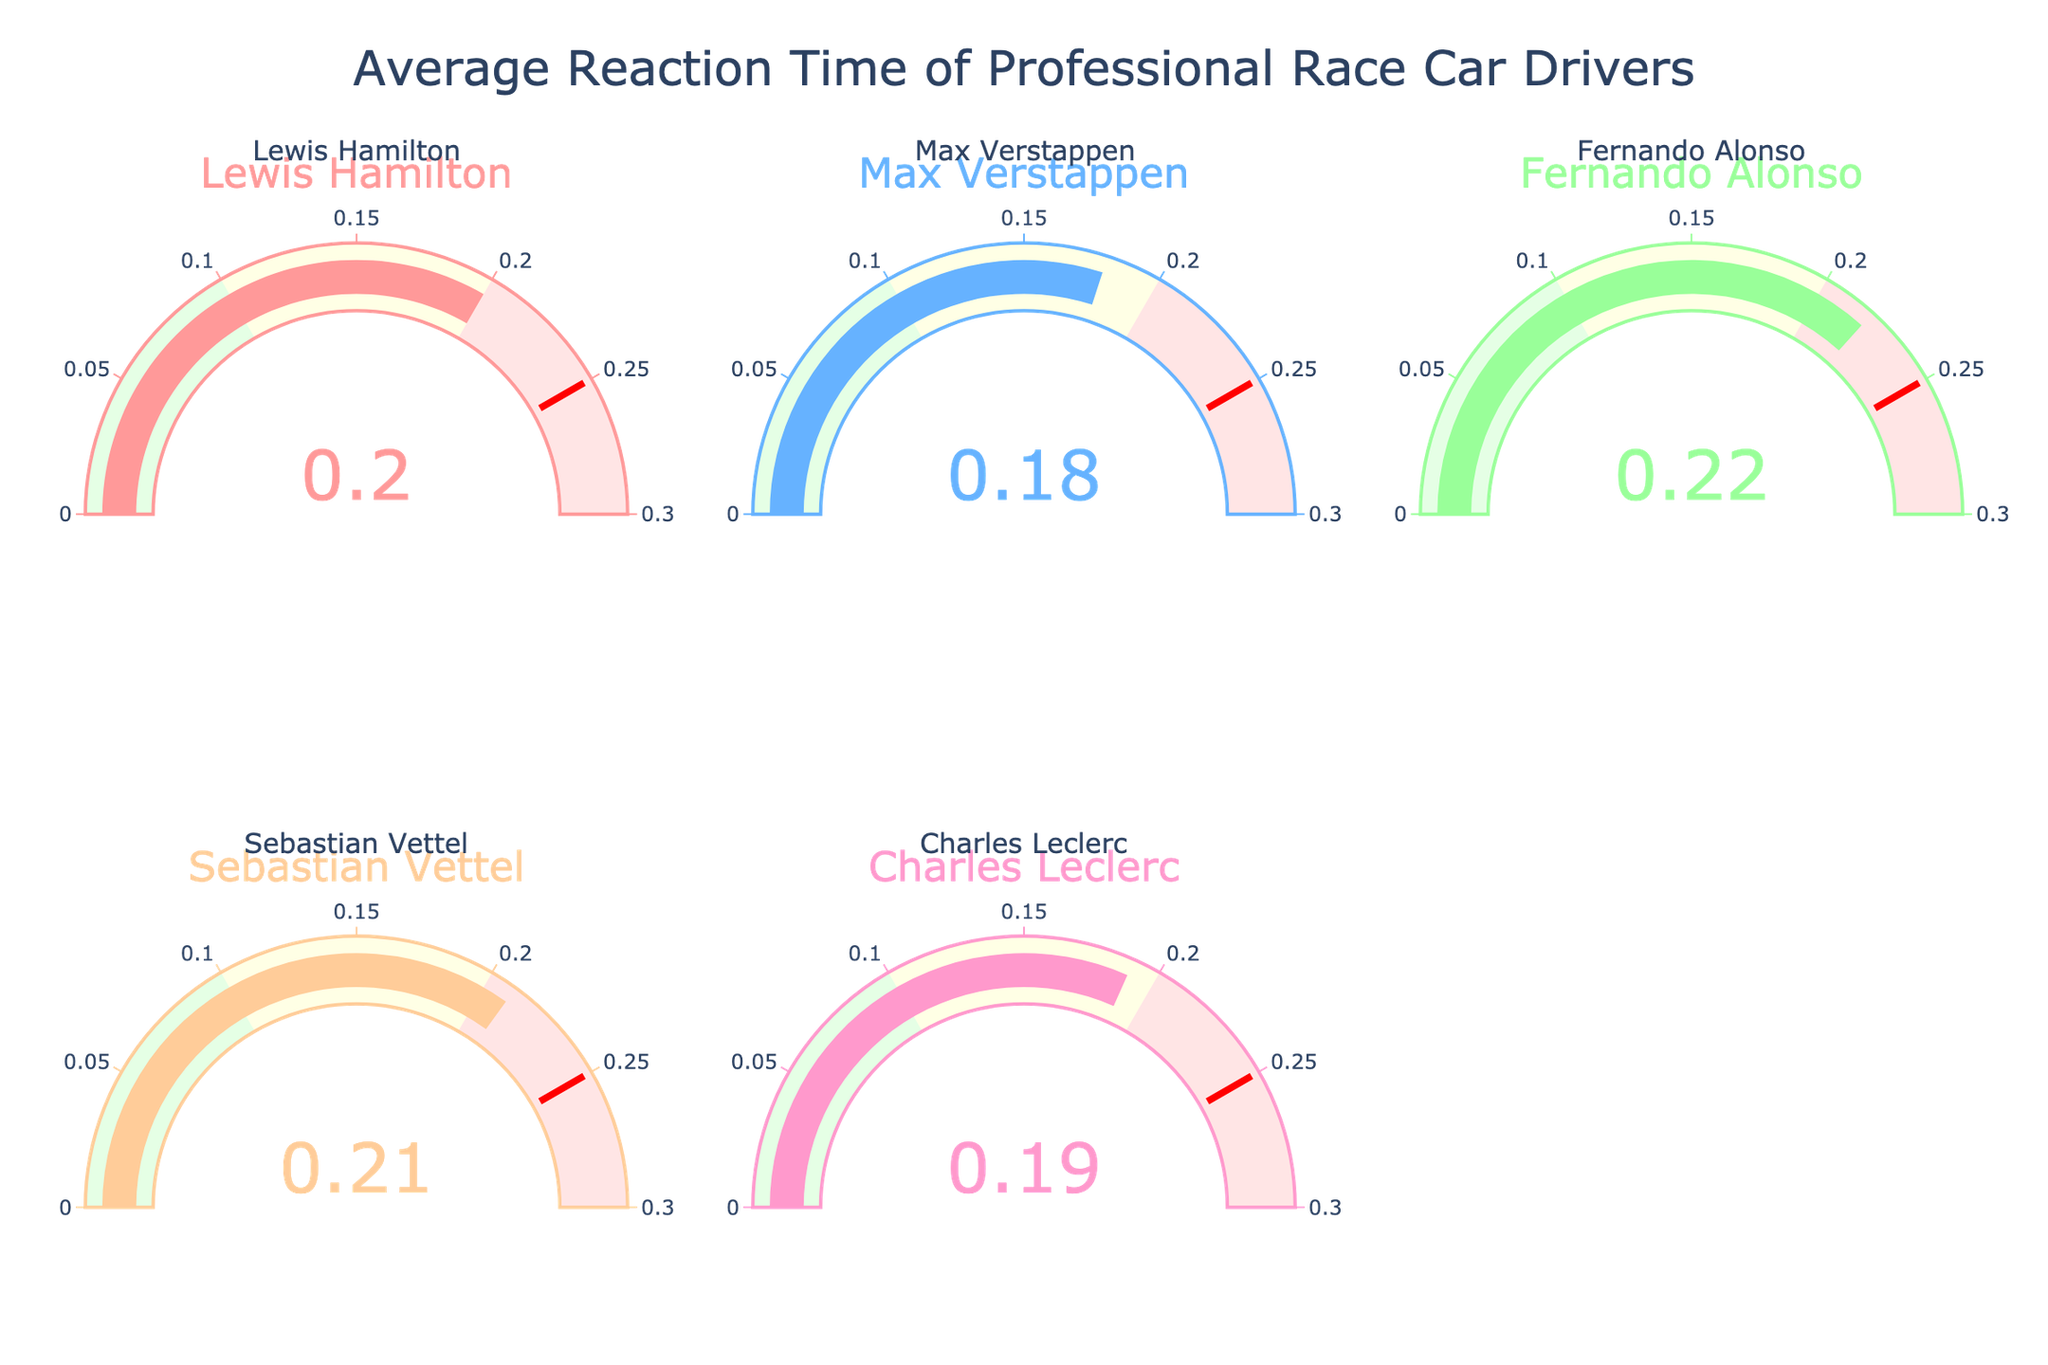What is the average reaction time displayed on the chart? Add up all the reaction times (0.20 + 0.18 + 0.22 + 0.21 + 0.19) which equals 1.00, and divide by the number of drivers (5) to find the average.
Answer: 0.20 Which driver has the fastest reaction time? Look at the values in each gauge to determine the smallest value.
Answer: Max Verstappen How much faster is Max Verstappen's reaction time compared to Sebastian Vettel's? Subtract Sebastian Vettel's reaction time (0.21) from Max Verstappen's reaction time (0.18).
Answer: 0.03 Do any drivers have the same reaction time? Examine the values in each gauge to see if any of them are equal.
Answer: No 